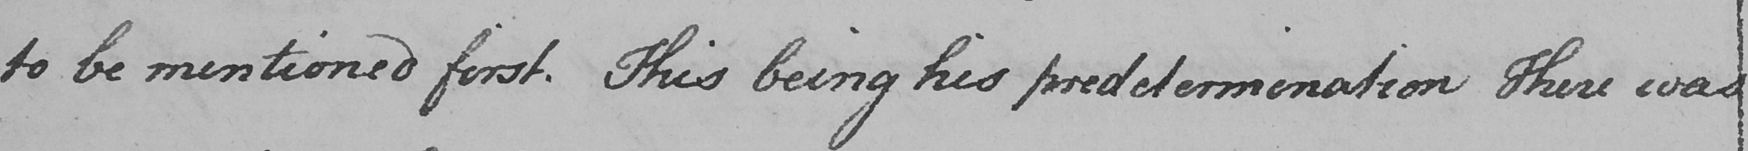Please provide the text content of this handwritten line. to be mentioned first . This being his predetermination There was 